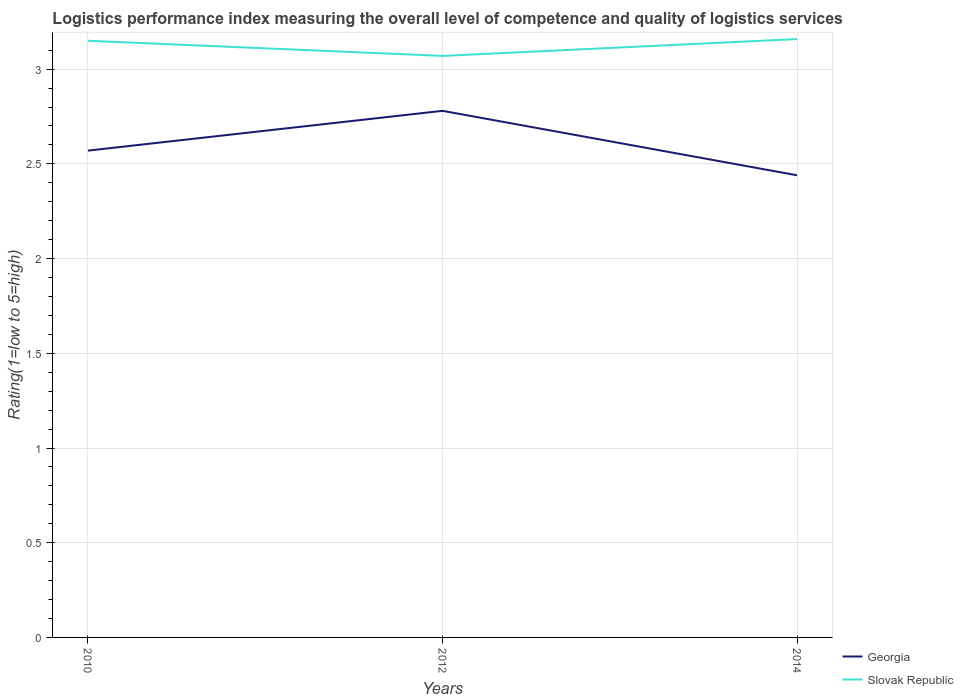How many different coloured lines are there?
Your response must be concise. 2. Is the number of lines equal to the number of legend labels?
Give a very brief answer. Yes. Across all years, what is the maximum Logistic performance index in Georgia?
Your answer should be compact. 2.44. In which year was the Logistic performance index in Georgia maximum?
Make the answer very short. 2014. What is the total Logistic performance index in Slovak Republic in the graph?
Provide a short and direct response. -0.09. What is the difference between the highest and the second highest Logistic performance index in Slovak Republic?
Offer a very short reply. 0.09. Is the Logistic performance index in Georgia strictly greater than the Logistic performance index in Slovak Republic over the years?
Provide a short and direct response. Yes. How many lines are there?
Your answer should be very brief. 2. Are the values on the major ticks of Y-axis written in scientific E-notation?
Your answer should be compact. No. Does the graph contain any zero values?
Your response must be concise. No. Where does the legend appear in the graph?
Ensure brevity in your answer.  Bottom right. How many legend labels are there?
Ensure brevity in your answer.  2. How are the legend labels stacked?
Your response must be concise. Vertical. What is the title of the graph?
Your answer should be very brief. Logistics performance index measuring the overall level of competence and quality of logistics services. What is the label or title of the Y-axis?
Give a very brief answer. Rating(1=low to 5=high). What is the Rating(1=low to 5=high) of Georgia in 2010?
Ensure brevity in your answer.  2.57. What is the Rating(1=low to 5=high) of Slovak Republic in 2010?
Keep it short and to the point. 3.15. What is the Rating(1=low to 5=high) in Georgia in 2012?
Offer a very short reply. 2.78. What is the Rating(1=low to 5=high) in Slovak Republic in 2012?
Make the answer very short. 3.07. What is the Rating(1=low to 5=high) of Georgia in 2014?
Give a very brief answer. 2.44. What is the Rating(1=low to 5=high) of Slovak Republic in 2014?
Your answer should be compact. 3.16. Across all years, what is the maximum Rating(1=low to 5=high) of Georgia?
Keep it short and to the point. 2.78. Across all years, what is the maximum Rating(1=low to 5=high) in Slovak Republic?
Your answer should be very brief. 3.16. Across all years, what is the minimum Rating(1=low to 5=high) in Georgia?
Provide a short and direct response. 2.44. Across all years, what is the minimum Rating(1=low to 5=high) in Slovak Republic?
Keep it short and to the point. 3.07. What is the total Rating(1=low to 5=high) of Georgia in the graph?
Provide a succinct answer. 7.79. What is the total Rating(1=low to 5=high) in Slovak Republic in the graph?
Offer a terse response. 9.38. What is the difference between the Rating(1=low to 5=high) in Georgia in 2010 and that in 2012?
Your answer should be very brief. -0.21. What is the difference between the Rating(1=low to 5=high) in Slovak Republic in 2010 and that in 2012?
Keep it short and to the point. 0.08. What is the difference between the Rating(1=low to 5=high) of Georgia in 2010 and that in 2014?
Your answer should be compact. 0.13. What is the difference between the Rating(1=low to 5=high) of Slovak Republic in 2010 and that in 2014?
Provide a short and direct response. -0.01. What is the difference between the Rating(1=low to 5=high) of Georgia in 2012 and that in 2014?
Provide a short and direct response. 0.34. What is the difference between the Rating(1=low to 5=high) in Slovak Republic in 2012 and that in 2014?
Keep it short and to the point. -0.09. What is the difference between the Rating(1=low to 5=high) in Georgia in 2010 and the Rating(1=low to 5=high) in Slovak Republic in 2014?
Ensure brevity in your answer.  -0.59. What is the difference between the Rating(1=low to 5=high) of Georgia in 2012 and the Rating(1=low to 5=high) of Slovak Republic in 2014?
Make the answer very short. -0.38. What is the average Rating(1=low to 5=high) in Georgia per year?
Your answer should be very brief. 2.6. What is the average Rating(1=low to 5=high) of Slovak Republic per year?
Make the answer very short. 3.13. In the year 2010, what is the difference between the Rating(1=low to 5=high) of Georgia and Rating(1=low to 5=high) of Slovak Republic?
Provide a short and direct response. -0.58. In the year 2012, what is the difference between the Rating(1=low to 5=high) of Georgia and Rating(1=low to 5=high) of Slovak Republic?
Your answer should be compact. -0.29. In the year 2014, what is the difference between the Rating(1=low to 5=high) in Georgia and Rating(1=low to 5=high) in Slovak Republic?
Provide a short and direct response. -0.72. What is the ratio of the Rating(1=low to 5=high) of Georgia in 2010 to that in 2012?
Offer a very short reply. 0.92. What is the ratio of the Rating(1=low to 5=high) of Slovak Republic in 2010 to that in 2012?
Ensure brevity in your answer.  1.03. What is the ratio of the Rating(1=low to 5=high) in Georgia in 2010 to that in 2014?
Provide a succinct answer. 1.05. What is the ratio of the Rating(1=low to 5=high) of Slovak Republic in 2010 to that in 2014?
Offer a terse response. 1. What is the ratio of the Rating(1=low to 5=high) of Georgia in 2012 to that in 2014?
Provide a succinct answer. 1.14. What is the ratio of the Rating(1=low to 5=high) in Slovak Republic in 2012 to that in 2014?
Your answer should be very brief. 0.97. What is the difference between the highest and the second highest Rating(1=low to 5=high) in Georgia?
Your response must be concise. 0.21. What is the difference between the highest and the second highest Rating(1=low to 5=high) of Slovak Republic?
Offer a terse response. 0.01. What is the difference between the highest and the lowest Rating(1=low to 5=high) in Georgia?
Your answer should be very brief. 0.34. What is the difference between the highest and the lowest Rating(1=low to 5=high) in Slovak Republic?
Provide a short and direct response. 0.09. 